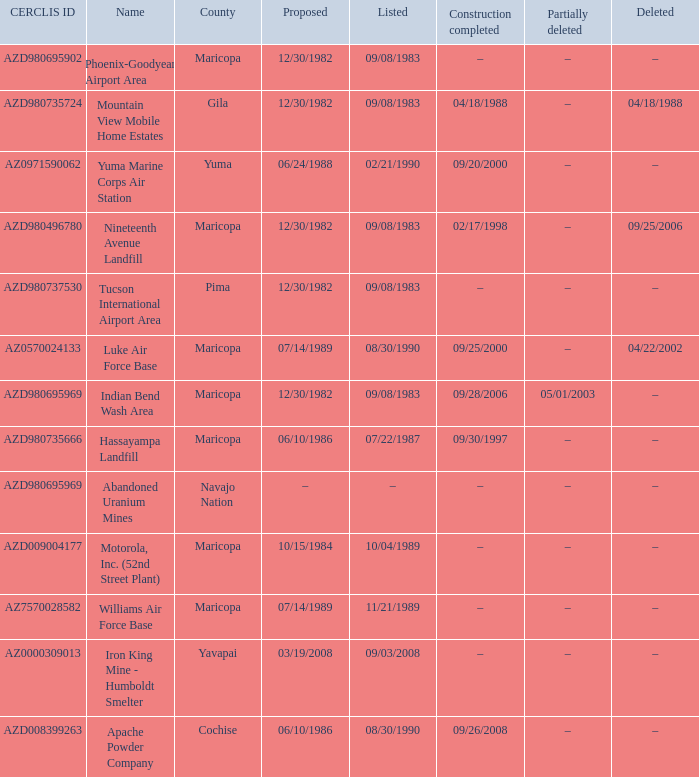What is the cerclis id when the site was proposed on 12/30/1982 and was partially deleted on 05/01/2003? AZD980695969. Can you parse all the data within this table? {'header': ['CERCLIS ID', 'Name', 'County', 'Proposed', 'Listed', 'Construction completed', 'Partially deleted', 'Deleted'], 'rows': [['AZD980695902', 'Phoenix-Goodyear Airport Area', 'Maricopa', '12/30/1982', '09/08/1983', '–', '–', '–'], ['AZD980735724', 'Mountain View Mobile Home Estates', 'Gila', '12/30/1982', '09/08/1983', '04/18/1988', '–', '04/18/1988'], ['AZ0971590062', 'Yuma Marine Corps Air Station', 'Yuma', '06/24/1988', '02/21/1990', '09/20/2000', '–', '–'], ['AZD980496780', 'Nineteenth Avenue Landfill', 'Maricopa', '12/30/1982', '09/08/1983', '02/17/1998', '–', '09/25/2006'], ['AZD980737530', 'Tucson International Airport Area', 'Pima', '12/30/1982', '09/08/1983', '–', '–', '–'], ['AZ0570024133', 'Luke Air Force Base', 'Maricopa', '07/14/1989', '08/30/1990', '09/25/2000', '–', '04/22/2002'], ['AZD980695969', 'Indian Bend Wash Area', 'Maricopa', '12/30/1982', '09/08/1983', '09/28/2006', '05/01/2003', '–'], ['AZD980735666', 'Hassayampa Landfill', 'Maricopa', '06/10/1986', '07/22/1987', '09/30/1997', '–', '–'], ['AZD980695969', 'Abandoned Uranium Mines', 'Navajo Nation', '–', '–', '–', '–', '–'], ['AZD009004177', 'Motorola, Inc. (52nd Street Plant)', 'Maricopa', '10/15/1984', '10/04/1989', '–', '–', '–'], ['AZ7570028582', 'Williams Air Force Base', 'Maricopa', '07/14/1989', '11/21/1989', '–', '–', '–'], ['AZ0000309013', 'Iron King Mine - Humboldt Smelter', 'Yavapai', '03/19/2008', '09/03/2008', '–', '–', '–'], ['AZD008399263', 'Apache Powder Company', 'Cochise', '06/10/1986', '08/30/1990', '09/26/2008', '–', '–']]} 